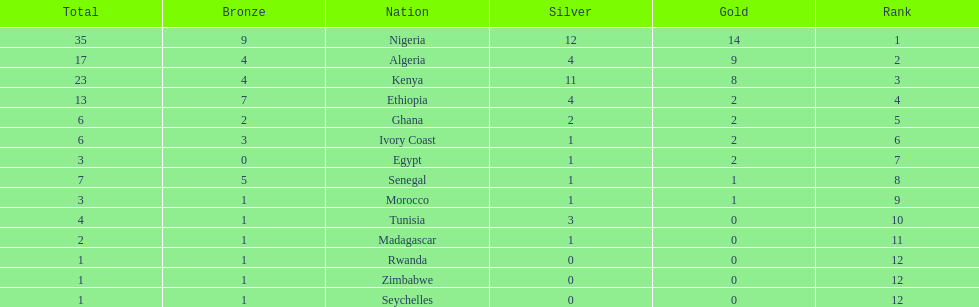What is the name of the first nation on this chart? Nigeria. 